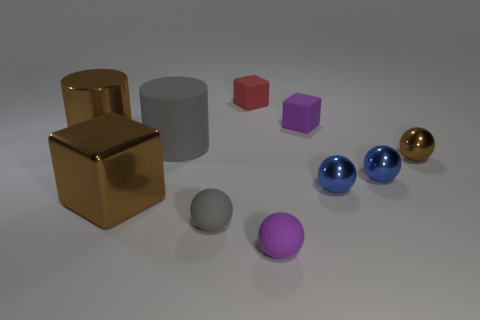Subtract all blue spheres. How many were subtracted if there are1blue spheres left? 1 Subtract all blue metal balls. How many balls are left? 3 Subtract all brown cylinders. How many blue balls are left? 2 Subtract all cubes. How many objects are left? 7 Subtract 3 spheres. How many spheres are left? 2 Subtract all purple cylinders. Subtract all purple blocks. How many cylinders are left? 2 Subtract all brown metallic things. Subtract all tiny blue metal spheres. How many objects are left? 5 Add 7 small rubber balls. How many small rubber balls are left? 9 Add 8 large brown metallic cylinders. How many large brown metallic cylinders exist? 9 Subtract all purple spheres. How many spheres are left? 4 